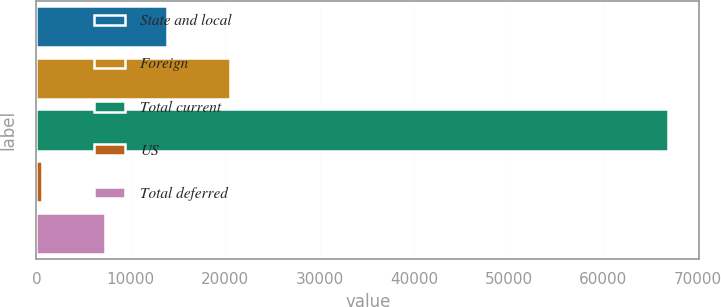Convert chart to OTSL. <chart><loc_0><loc_0><loc_500><loc_500><bar_chart><fcel>State and local<fcel>Foreign<fcel>Total current<fcel>US<fcel>Total deferred<nl><fcel>13845.2<fcel>20471.8<fcel>66858<fcel>592<fcel>7218.6<nl></chart> 